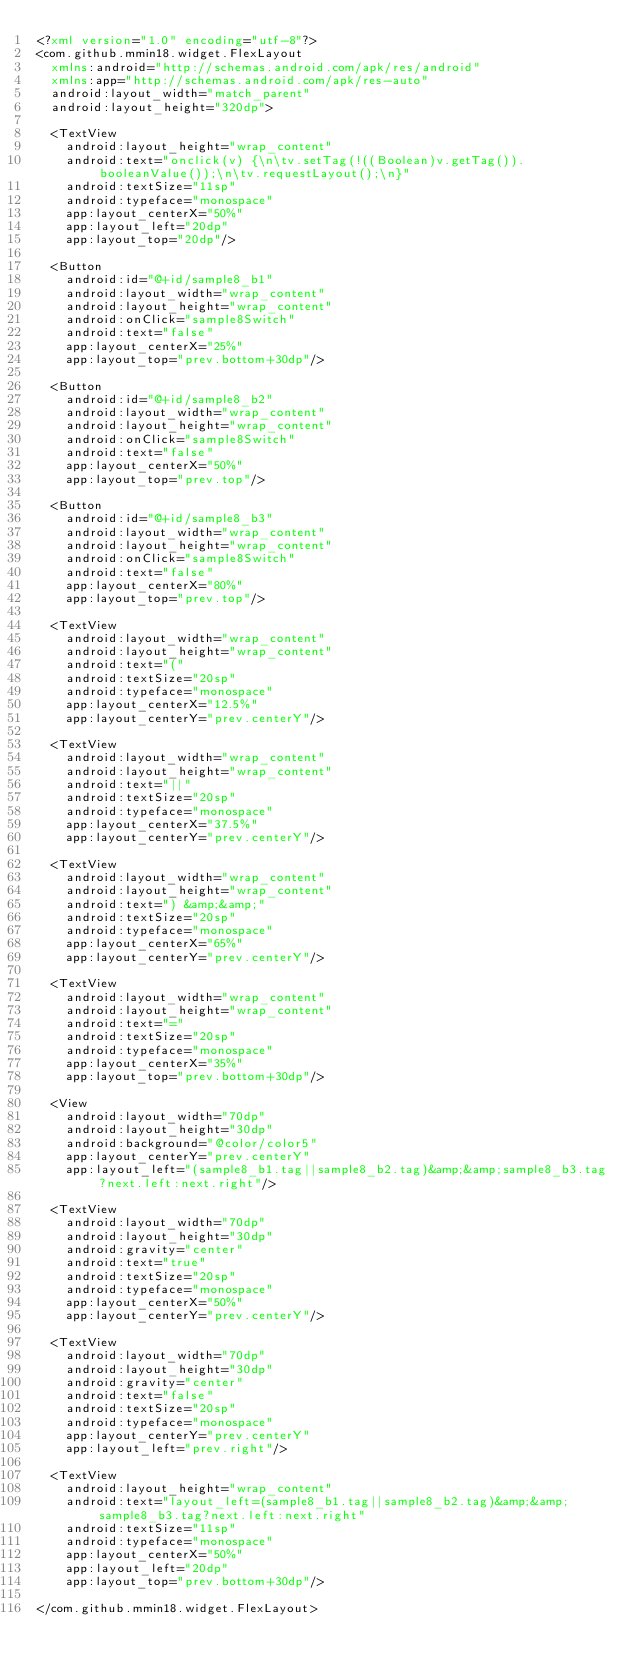<code> <loc_0><loc_0><loc_500><loc_500><_XML_><?xml version="1.0" encoding="utf-8"?>
<com.github.mmin18.widget.FlexLayout
	xmlns:android="http://schemas.android.com/apk/res/android"
	xmlns:app="http://schemas.android.com/apk/res-auto"
	android:layout_width="match_parent"
	android:layout_height="320dp">

	<TextView
		android:layout_height="wrap_content"
		android:text="onclick(v) {\n\tv.setTag(!((Boolean)v.getTag()).booleanValue());\n\tv.requestLayout();\n}"
		android:textSize="11sp"
		android:typeface="monospace"
		app:layout_centerX="50%"
		app:layout_left="20dp"
		app:layout_top="20dp"/>

	<Button
		android:id="@+id/sample8_b1"
		android:layout_width="wrap_content"
		android:layout_height="wrap_content"
		android:onClick="sample8Switch"
		android:text="false"
		app:layout_centerX="25%"
		app:layout_top="prev.bottom+30dp"/>

	<Button
		android:id="@+id/sample8_b2"
		android:layout_width="wrap_content"
		android:layout_height="wrap_content"
		android:onClick="sample8Switch"
		android:text="false"
		app:layout_centerX="50%"
		app:layout_top="prev.top"/>

	<Button
		android:id="@+id/sample8_b3"
		android:layout_width="wrap_content"
		android:layout_height="wrap_content"
		android:onClick="sample8Switch"
		android:text="false"
		app:layout_centerX="80%"
		app:layout_top="prev.top"/>

	<TextView
		android:layout_width="wrap_content"
		android:layout_height="wrap_content"
		android:text="("
		android:textSize="20sp"
		android:typeface="monospace"
		app:layout_centerX="12.5%"
		app:layout_centerY="prev.centerY"/>

	<TextView
		android:layout_width="wrap_content"
		android:layout_height="wrap_content"
		android:text="||"
		android:textSize="20sp"
		android:typeface="monospace"
		app:layout_centerX="37.5%"
		app:layout_centerY="prev.centerY"/>

	<TextView
		android:layout_width="wrap_content"
		android:layout_height="wrap_content"
		android:text=") &amp;&amp;"
		android:textSize="20sp"
		android:typeface="monospace"
		app:layout_centerX="65%"
		app:layout_centerY="prev.centerY"/>

	<TextView
		android:layout_width="wrap_content"
		android:layout_height="wrap_content"
		android:text="="
		android:textSize="20sp"
		android:typeface="monospace"
		app:layout_centerX="35%"
		app:layout_top="prev.bottom+30dp"/>

	<View
		android:layout_width="70dp"
		android:layout_height="30dp"
		android:background="@color/color5"
		app:layout_centerY="prev.centerY"
		app:layout_left="(sample8_b1.tag||sample8_b2.tag)&amp;&amp;sample8_b3.tag?next.left:next.right"/>

	<TextView
		android:layout_width="70dp"
		android:layout_height="30dp"
		android:gravity="center"
		android:text="true"
		android:textSize="20sp"
		android:typeface="monospace"
		app:layout_centerX="50%"
		app:layout_centerY="prev.centerY"/>

	<TextView
		android:layout_width="70dp"
		android:layout_height="30dp"
		android:gravity="center"
		android:text="false"
		android:textSize="20sp"
		android:typeface="monospace"
		app:layout_centerY="prev.centerY"
		app:layout_left="prev.right"/>

	<TextView
		android:layout_height="wrap_content"
		android:text="layout_left=(sample8_b1.tag||sample8_b2.tag)&amp;&amp;sample8_b3.tag?next.left:next.right"
		android:textSize="11sp"
		android:typeface="monospace"
		app:layout_centerX="50%"
		app:layout_left="20dp"
		app:layout_top="prev.bottom+30dp"/>

</com.github.mmin18.widget.FlexLayout></code> 